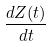Convert formula to latex. <formula><loc_0><loc_0><loc_500><loc_500>\frac { d Z ( t ) } { d t }</formula> 